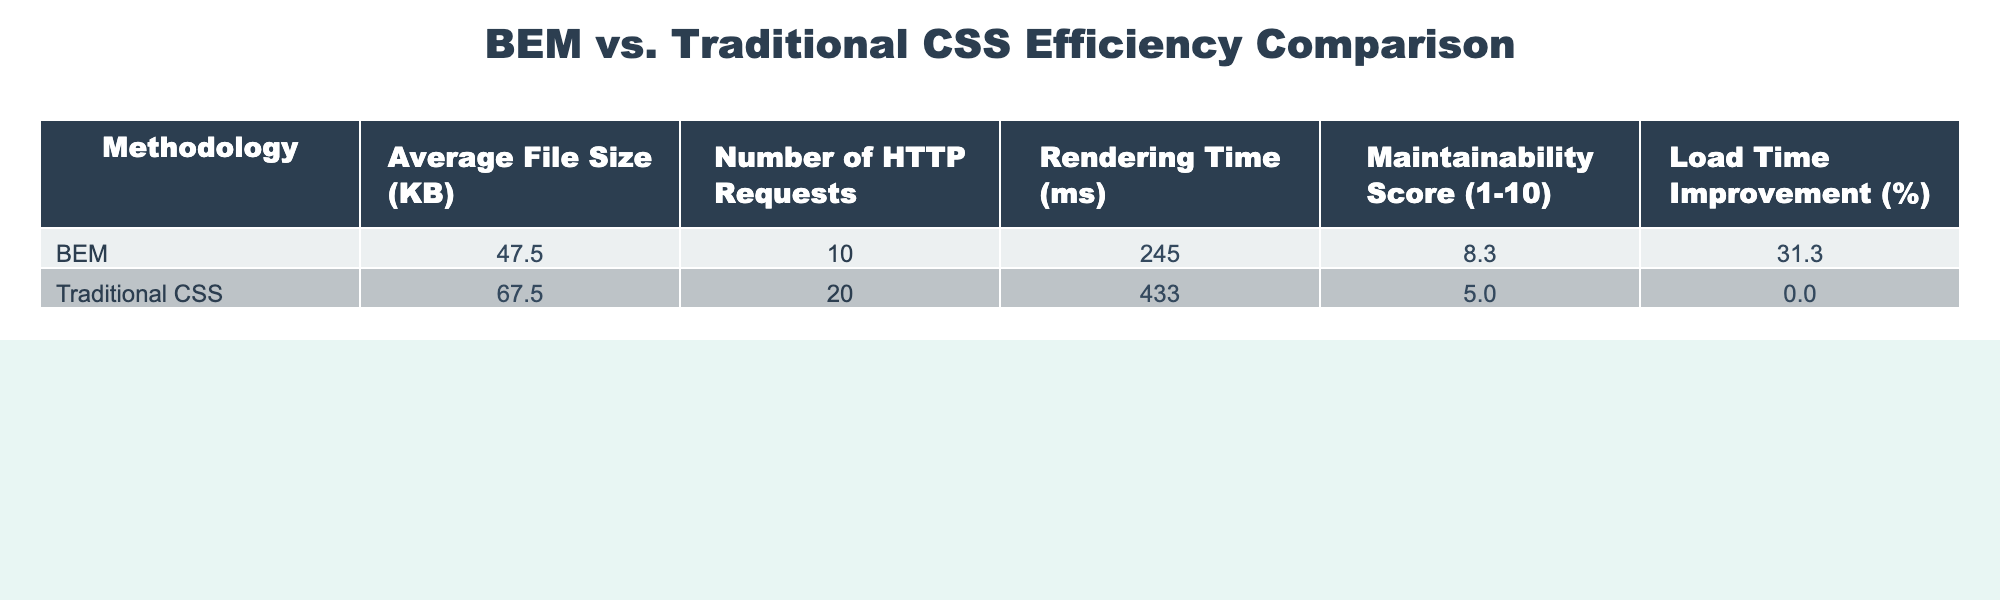What is the average maintainability score for BEM? To find the average maintainability score for BEM, we need to calculate the mean of the scores (9, 8, 9, 7) which sums to 33, and then divide by the number of entries, which is 4. Thus, 33 / 4 = 8.25.
Answer: 8.25 What is the average file size for Traditional CSS? The average file size for Traditional CSS can be calculated by summing the file sizes (70, 75, 60, 65) to get a total of 270 and dividing by the number of entries, which is 4. This gives us 270 / 4 = 67.5.
Answer: 67.5 Which methodology has a higher average load time improvement? BEM has an average load time improvement of 30% and 35% and 28% and 32%, totaling 125%, averaging 31.25%. Traditional CSS has a load time improvement of 0% across all entries. Therefore, BEM has the higher average.
Answer: BEM What is the difference in the average rendering time between BEM and Traditional CSS? First, calculate the average rendering time for BEM (250 + 240 + 230 + 260 = 980; 980 / 4 = 245) and for Traditional CSS (400 + 450 + 420 + 460 = 1730; 1730 / 4 = 432.5). The difference is 432.5 - 245 = 187.5 ms.
Answer: 187.5 ms Is the average number of HTTP requests for BEM lower than that for Traditional CSS? BEM has an average of 10, 12, and 8, totaling 30, averaging to 10. Traditional CSS has an average of 20, leading to the conclusion that BEM's average is lower than Traditional CSS.
Answer: Yes What is the total load time improvement for all entries of BEM? The load time improvements for BEM are 30%, 35%, 28%, and 32%. Summing these values gives 125%.
Answer: 125% Which methodology has a higher average file size and by how much? BEM has an average size of 48.75 KB (45 + 50 + 40 + 55) / 4 and Traditional CSS has 67.5 KB. The difference is 67.5 - 48.75 = 18.75 KB, meaning Traditional CSS is larger.
Answer: 18.75 KB What is the average rendering time across both methodologies? For BEM, the average rendering time is 245 ms, while for Traditional CSS, it is 432.5 ms. The overall average is (245 + 432.5) / 2 = 338.75 ms.
Answer: 338.75 ms Does BEM consistently outperform Traditional CSS in all metrics presented? Upon reviewing the metrics, BEM outperforms Traditional CSS in average file size, number of HTTP requests, rendering time, and maintainability score, but not in load time improvement which is uniformly zero for Traditional CSS.
Answer: No What percentage of entries for Traditional CSS have a rendering time over 400 ms? There are 4 entries for Traditional CSS, and all 4 (400, 450, 420, and 460) exceed 400 ms, resulting in 4 out of 4 entries, which is 100%.
Answer: 100% 